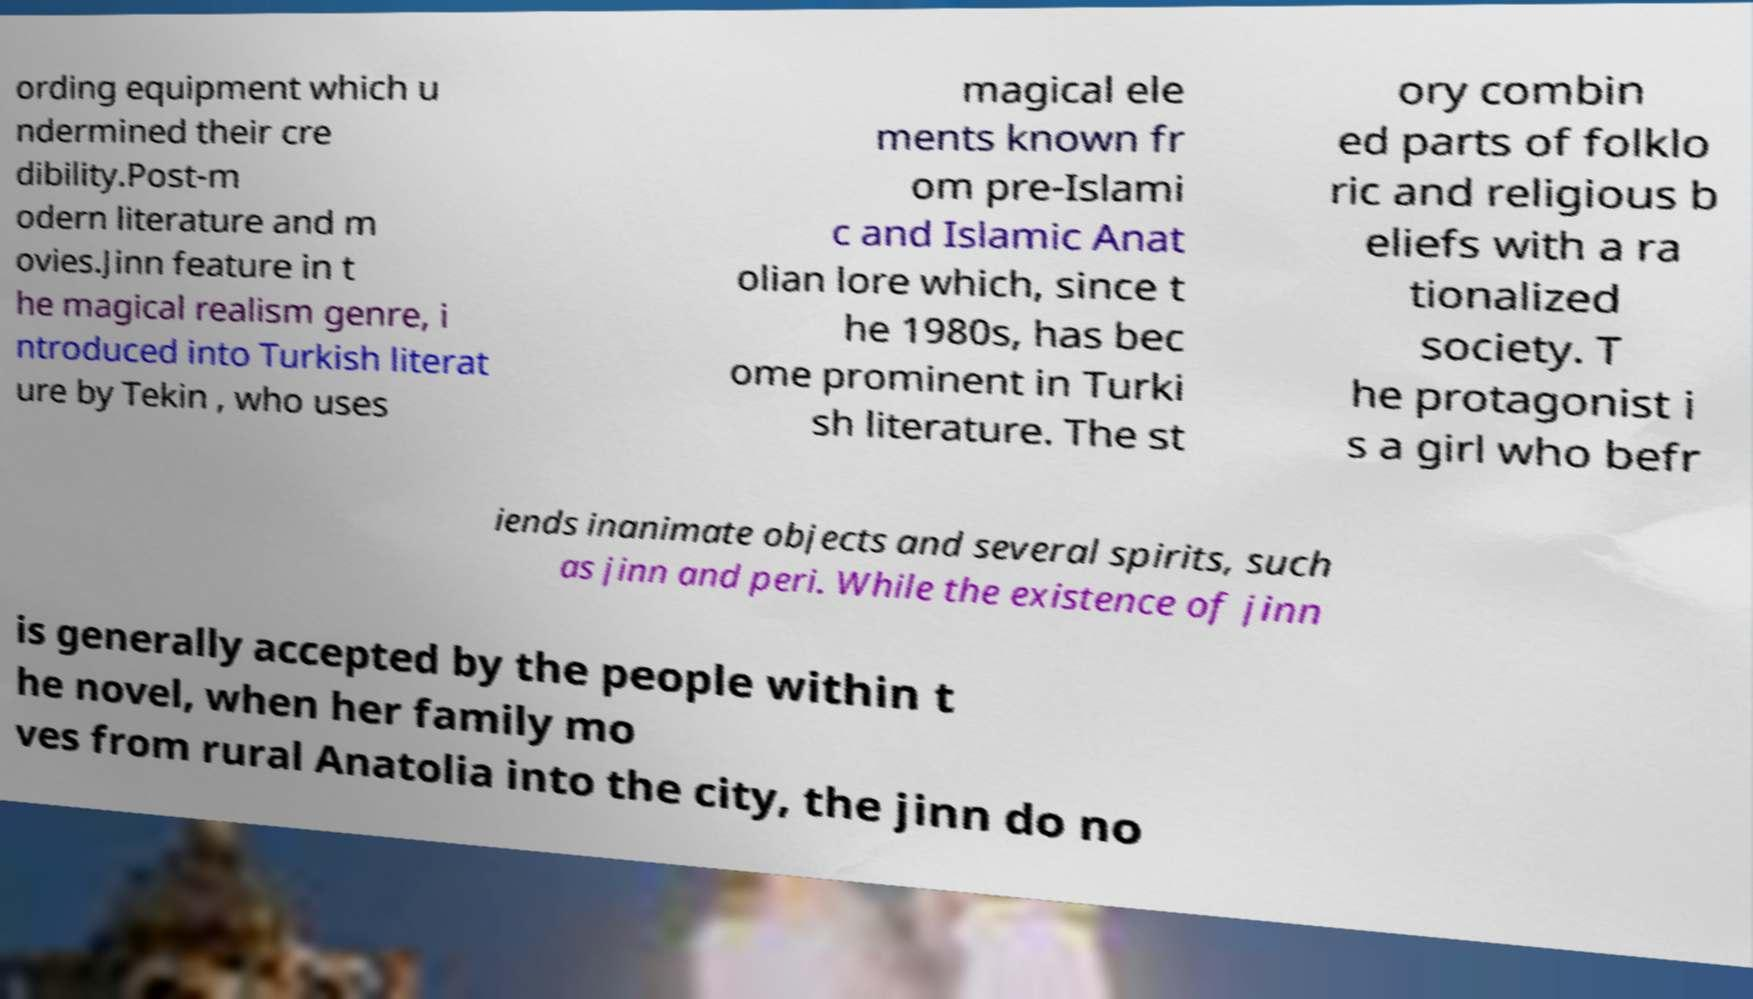There's text embedded in this image that I need extracted. Can you transcribe it verbatim? ording equipment which u ndermined their cre dibility.Post-m odern literature and m ovies.Jinn feature in t he magical realism genre, i ntroduced into Turkish literat ure by Tekin , who uses magical ele ments known fr om pre-Islami c and Islamic Anat olian lore which, since t he 1980s, has bec ome prominent in Turki sh literature. The st ory combin ed parts of folklo ric and religious b eliefs with a ra tionalized society. T he protagonist i s a girl who befr iends inanimate objects and several spirits, such as jinn and peri. While the existence of jinn is generally accepted by the people within t he novel, when her family mo ves from rural Anatolia into the city, the jinn do no 